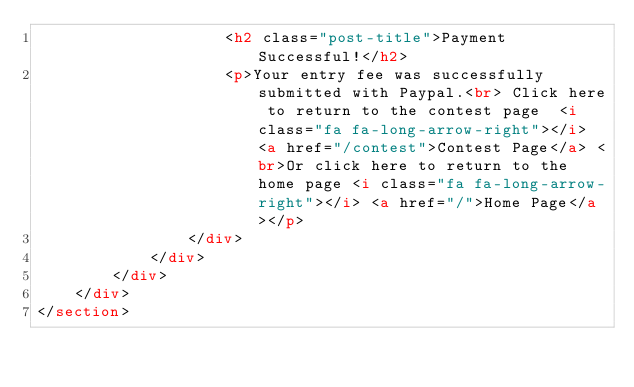Convert code to text. <code><loc_0><loc_0><loc_500><loc_500><_HTML_>                    <h2 class="post-title">Payment Successful!</h2>
                    <p>Your entry fee was successfully submitted with Paypal.<br> Click here to return to the contest page  <i class="fa fa-long-arrow-right"></i>  <a href="/contest">Contest Page</a> <br>Or click here to return to the home page <i class="fa fa-long-arrow-right"></i> <a href="/">Home Page</a></p>
                </div>
            </div>
        </div>
    </div>
</section></code> 